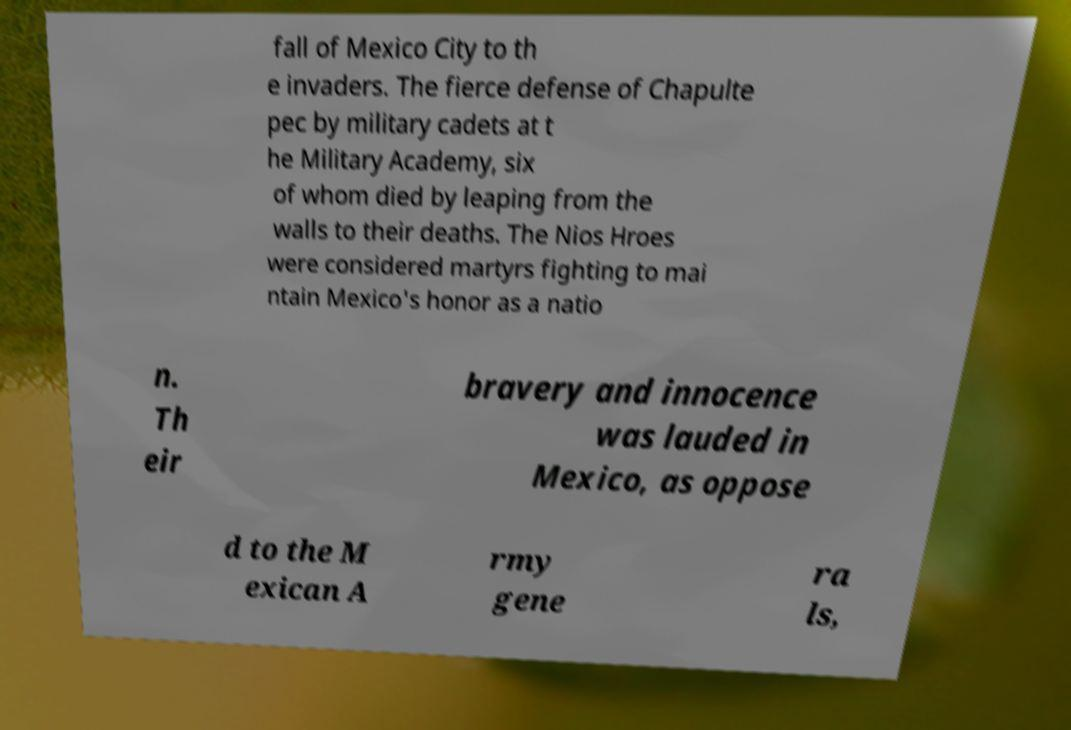Please identify and transcribe the text found in this image. fall of Mexico City to th e invaders. The fierce defense of Chapulte pec by military cadets at t he Military Academy, six of whom died by leaping from the walls to their deaths. The Nios Hroes were considered martyrs fighting to mai ntain Mexico's honor as a natio n. Th eir bravery and innocence was lauded in Mexico, as oppose d to the M exican A rmy gene ra ls, 